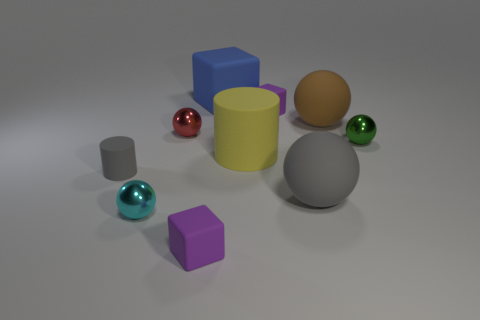Subtract all blue spheres. Subtract all blue cylinders. How many spheres are left? 5 Subtract all cubes. How many objects are left? 7 Add 3 large cubes. How many large cubes are left? 4 Add 5 big yellow metal things. How many big yellow metal things exist? 5 Subtract 2 purple cubes. How many objects are left? 8 Subtract all big cyan things. Subtract all gray matte spheres. How many objects are left? 9 